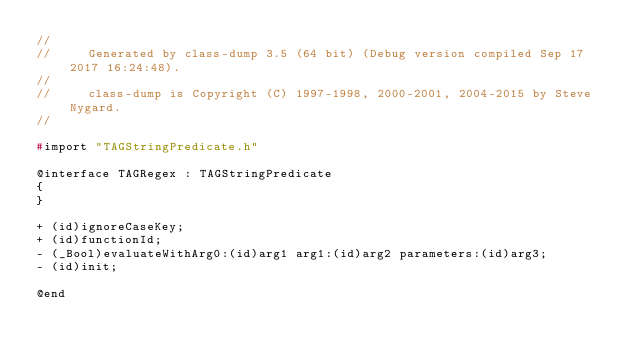<code> <loc_0><loc_0><loc_500><loc_500><_C_>//
//     Generated by class-dump 3.5 (64 bit) (Debug version compiled Sep 17 2017 16:24:48).
//
//     class-dump is Copyright (C) 1997-1998, 2000-2001, 2004-2015 by Steve Nygard.
//

#import "TAGStringPredicate.h"

@interface TAGRegex : TAGStringPredicate
{
}

+ (id)ignoreCaseKey;
+ (id)functionId;
- (_Bool)evaluateWithArg0:(id)arg1 arg1:(id)arg2 parameters:(id)arg3;
- (id)init;

@end

</code> 